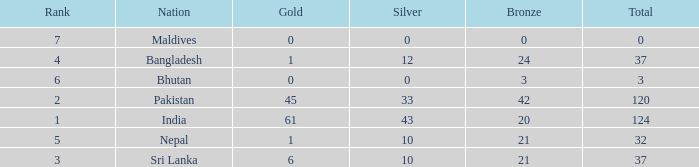How much Silver has a Rank of 7? 1.0. 